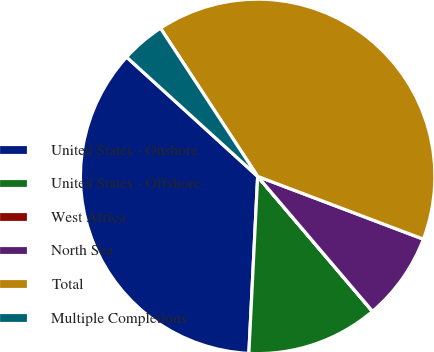Convert chart. <chart><loc_0><loc_0><loc_500><loc_500><pie_chart><fcel>United States - Onshore<fcel>United States - Offshore<fcel>West Africa<fcel>North Sea<fcel>Total<fcel>Multiple Completions<nl><fcel>35.97%<fcel>12.01%<fcel>0.01%<fcel>8.01%<fcel>40.01%<fcel>4.01%<nl></chart> 